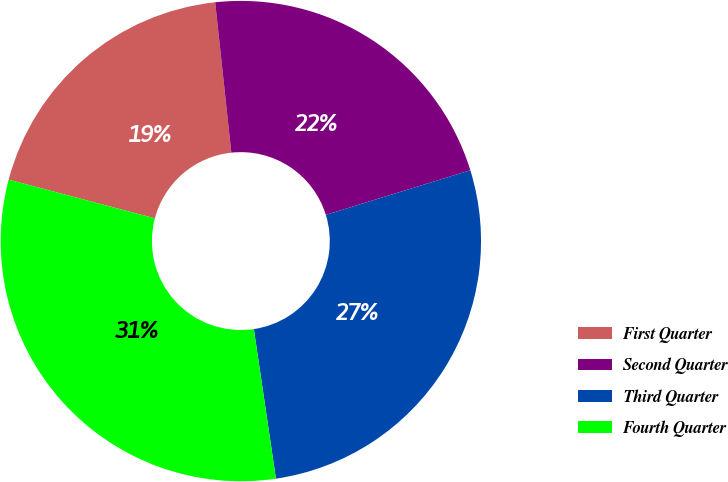Convert chart to OTSL. <chart><loc_0><loc_0><loc_500><loc_500><pie_chart><fcel>First Quarter<fcel>Second Quarter<fcel>Third Quarter<fcel>Fourth Quarter<nl><fcel>19.18%<fcel>21.94%<fcel>27.43%<fcel>31.45%<nl></chart> 